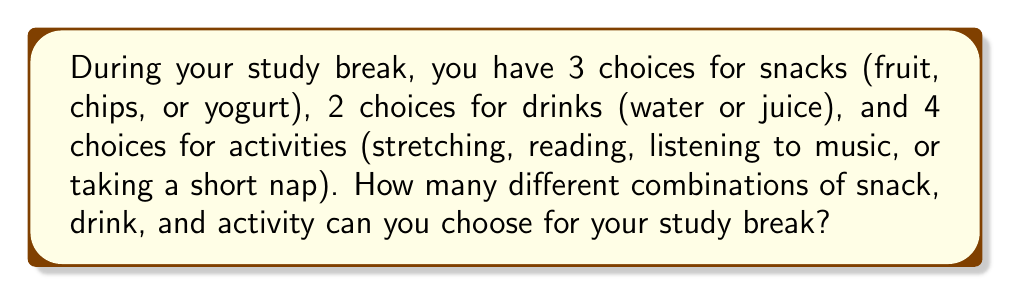Could you help me with this problem? Let's break this down step-by-step:

1. We need to use the multiplication principle of counting for this problem.

2. For each choice (snack, drink, and activity), we multiply the number of options:

   $$ \text{Total combinations} = \text{Snack options} \times \text{Drink options} \times \text{Activity options} $$

3. Let's plug in the numbers:
   - Snack options: 3 (fruit, chips, or yogurt)
   - Drink options: 2 (water or juice)
   - Activity options: 4 (stretching, reading, listening to music, or taking a short nap)

4. Now we can calculate:

   $$ \text{Total combinations} = 3 \times 2 \times 4 = 24 $$

Therefore, there are 24 different possible combinations for your study break.
Answer: 24 combinations 